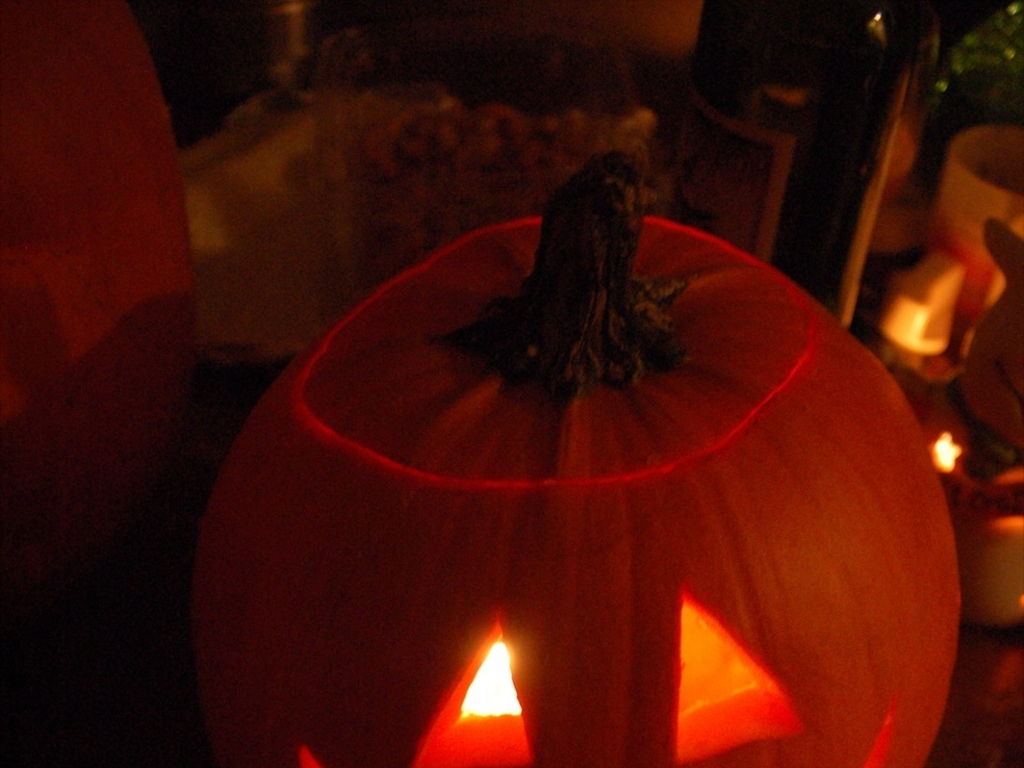How clear is the subject, the pumpkin lantern?
A. Clear
B. Indistinct
C. Blurry
D. Uncertain
Answer with the option's letter from the given choices directly.
 A. 